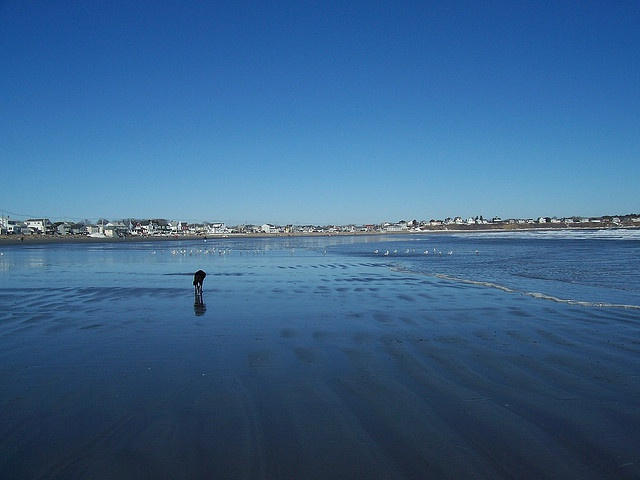Describe the objects in this image and their specific colors. I can see bird in darkblue, gray, and blue tones, dog in darkblue, black, and gray tones, bird in darkblue, gray, blue, and darkgray tones, bird in darkblue, darkgray, blue, and gray tones, and bird in darkblue, blue, gray, and darkgray tones in this image. 